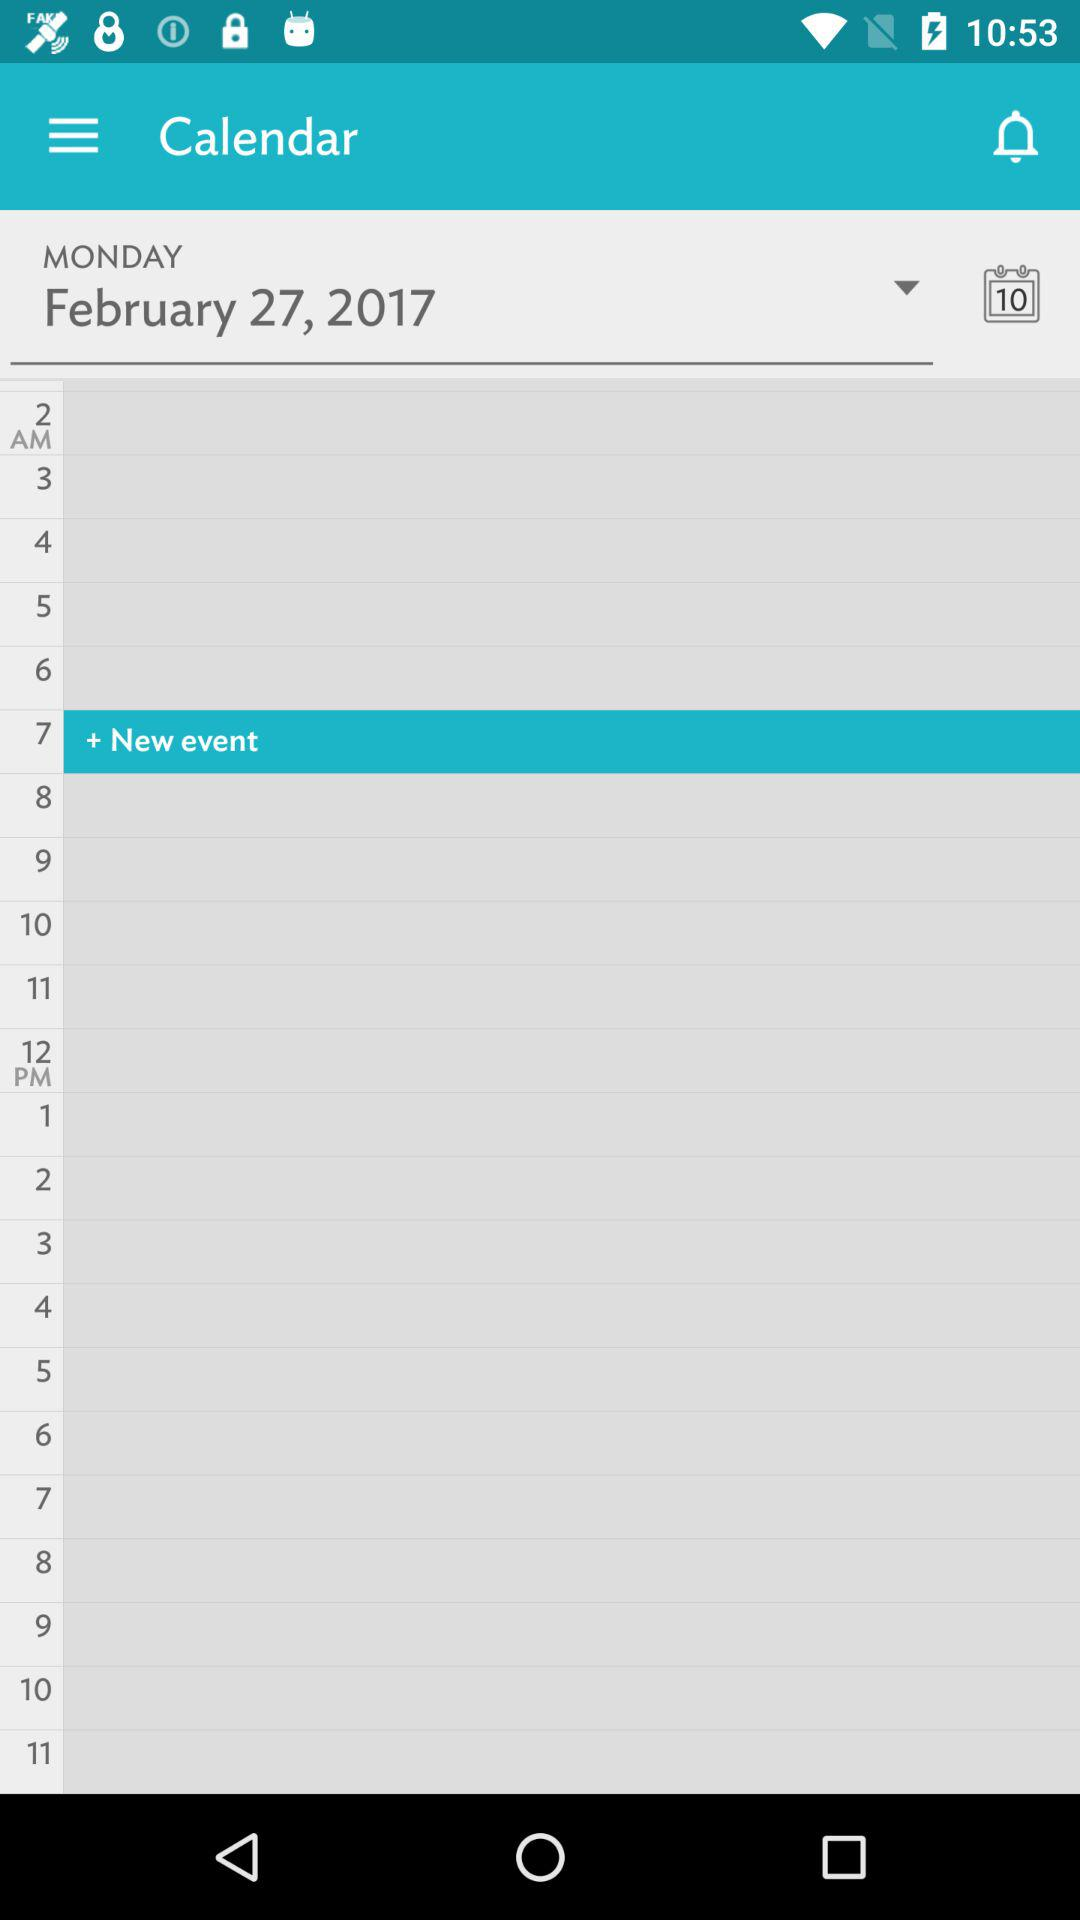What is the date selected on the calendar? The selected date is Monday, February 27, 2017. 